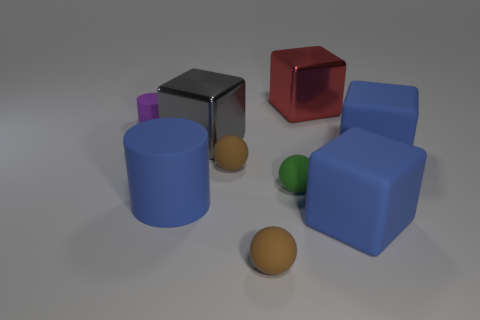Can you describe the textures of the objects? Certainly! The objects exhibit a matte finish with smooth surfaces, devoid of any visible texture or glossiness, which gives each item a soft, non-reflective look. Do any of the objects have reflective surfaces? In this image, all of the objects have a matte finish and do not possess reflective properties. They absorb light rather than reflecting it, which contributes to their modest visual appearance. 